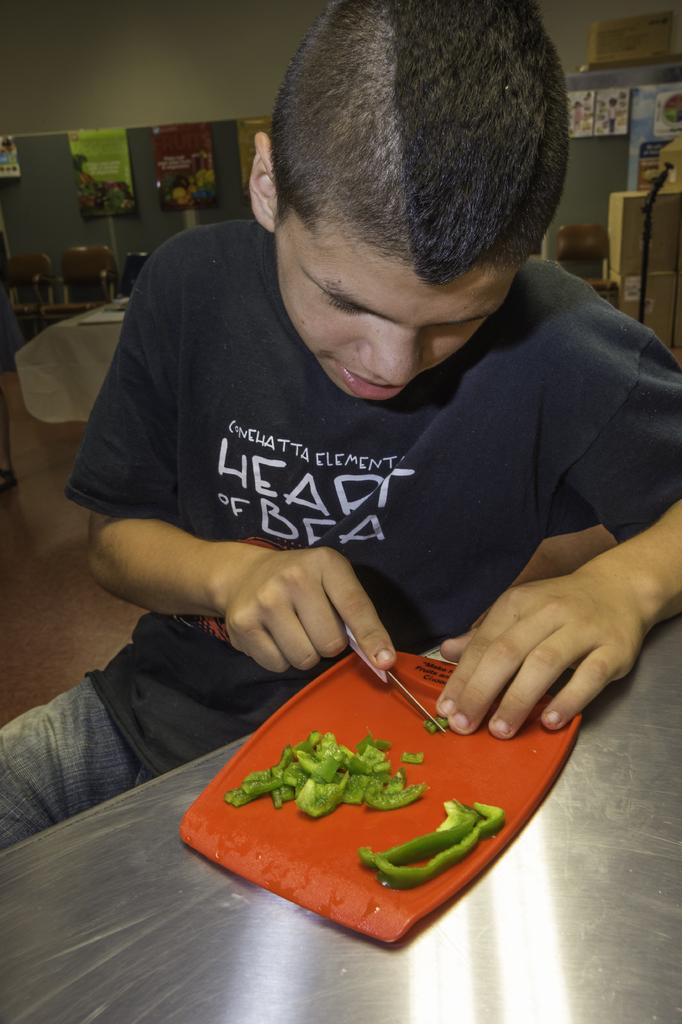What is the man in the image doing? The man is sitting on a chair in the image. What is in front of the man? The man is in front of a table. What is on the table in front of the man? There is a tray, a knife, and a capsicum on the table. What can be seen in the background of the image? In the background, there is another table and chairs. What team does the man belong to in the image? There is no indication of a team or any affiliation in the image. What type of land can be seen in the background of the image? There is no land visible in the image; the image only shows a man sitting in front of a table and chairs in the background. 